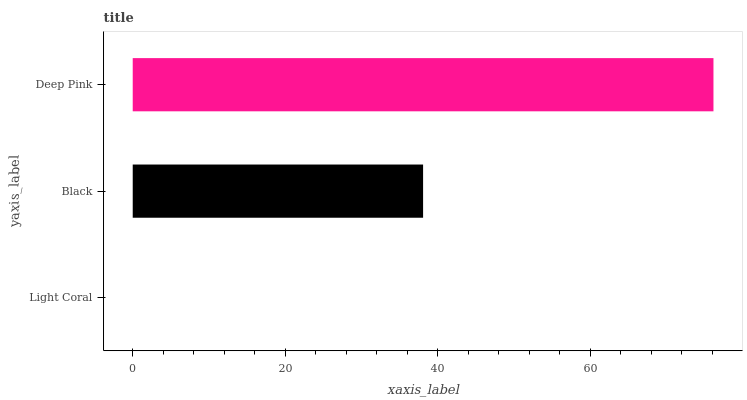Is Light Coral the minimum?
Answer yes or no. Yes. Is Deep Pink the maximum?
Answer yes or no. Yes. Is Black the minimum?
Answer yes or no. No. Is Black the maximum?
Answer yes or no. No. Is Black greater than Light Coral?
Answer yes or no. Yes. Is Light Coral less than Black?
Answer yes or no. Yes. Is Light Coral greater than Black?
Answer yes or no. No. Is Black less than Light Coral?
Answer yes or no. No. Is Black the high median?
Answer yes or no. Yes. Is Black the low median?
Answer yes or no. Yes. Is Deep Pink the high median?
Answer yes or no. No. Is Light Coral the low median?
Answer yes or no. No. 